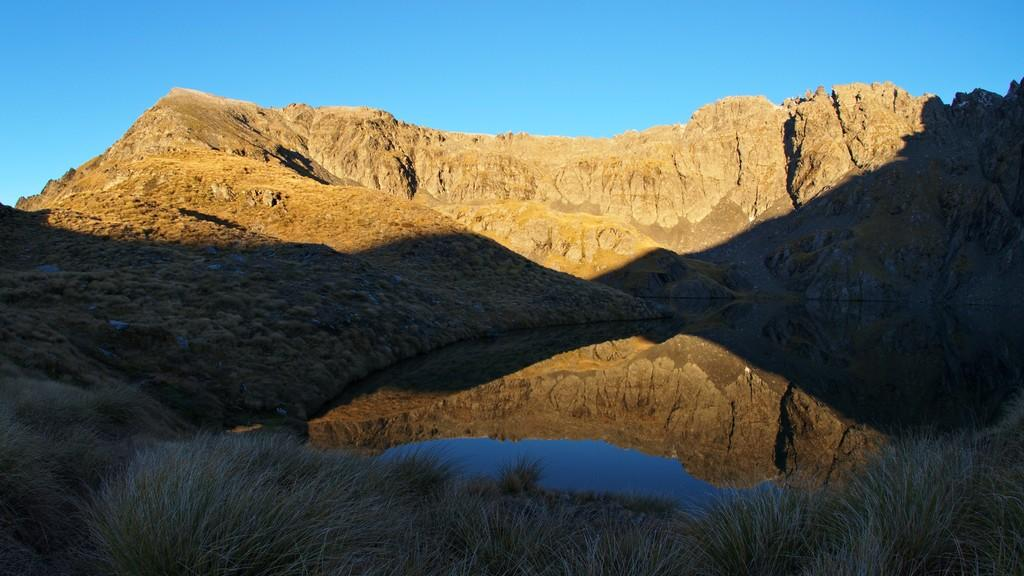What type of natural landscape is depicted in the image? The image features mountains. What can be seen at the bottom of the image? There is water and grass visible at the bottom of the image. What is visible at the top of the image? The sky is visible at the top of the image. How many wounds can be seen on the mountains in the image? There are no wounds present on the mountains in the image. What type of flower is growing on the mountains in the image? There is no flower, specifically a rose, present on the mountains in the image. 